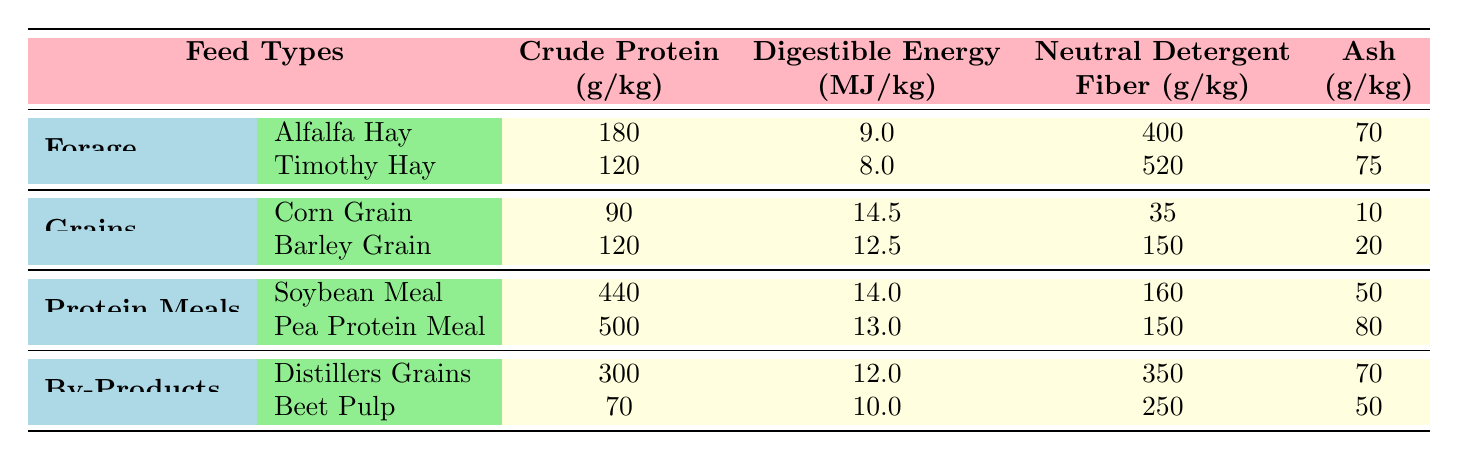What is the crude protein content of Alfalfa Hay? From the table, under the Forage category, the row for Alfalfa Hay shows that the crude protein content is listed as 180 g/kg.
Answer: 180 g/kg Which feed type has the highest digestible energy? Looking at the Digestible Energy column across all feed types, Corn Grain has the highest value at 14.5 MJ/kg.
Answer: Corn Grain What is the average crude protein content of the grains listed? The crude protein values for Corn Grain and Barley Grain are 90 g/kg and 120 g/kg, respectively. To find the average, add these values (90 + 120 = 210) and divide by the number of feed types (210 / 2 = 105).
Answer: 105 g/kg Is the neutral detergent fiber content of Beet Pulp higher than that of Soybean Meal? The Neutral Detergent Fiber value for Beet Pulp is 250 g/kg, while for Soybean Meal, it is 160 g/kg. Since 250 is greater than 160, the statement is true.
Answer: Yes Which category of feed types has the lowest ash content on average? The ash contents are as follows: Forage (average: (70 + 75)/2 = 72.5 g/kg), Grains (average: (10 + 20)/2 = 15 g/kg), Protein Meals (average: (50 + 80)/2 = 65 g/kg), By-Products (average: (70 + 50)/2 = 60 g/kg). The lowest average ash content is for Grains.
Answer: Grains What is the total digestible energy for all types of protein meals combined? Summing up the Digestible Energy values for Soybean Meal (14.0 MJ/kg) and Pea Protein Meal (13.0 MJ/kg), we have 14.0 + 13.0 = 27.0 MJ/kg.
Answer: 27.0 MJ/kg Does Distillers Grains contain more crude protein than Corn Grain? Distillers Grains has a crude protein content of 300 g/kg, while Corn Grain has 90 g/kg. Since 300 is greater than 90, the answer is yes.
Answer: Yes What is the neutral detergent fiber content difference between Timothy Hay and Barley Grain? The Neutral Detergent Fiber for Timothy Hay is 520 g/kg and for Barley Grain is 150 g/kg. The difference is calculated by subtracting 150 from 520, resulting in 370 g/kg.
Answer: 370 g/kg Which feed types belong to the Forage category? The table lists Alfalfa Hay and Timothy Hay under the Forage category.
Answer: Alfalfa Hay and Timothy Hay 